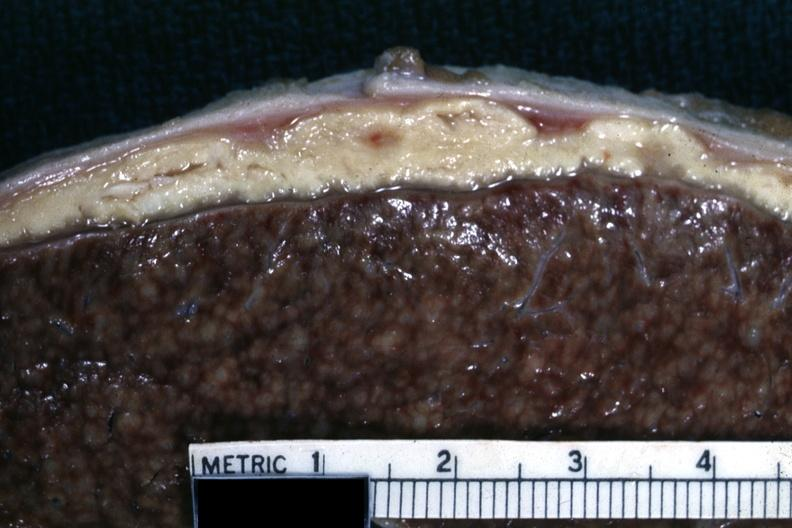how is this abscess material very typical?
Answer the question using a single word or phrase. Cold 